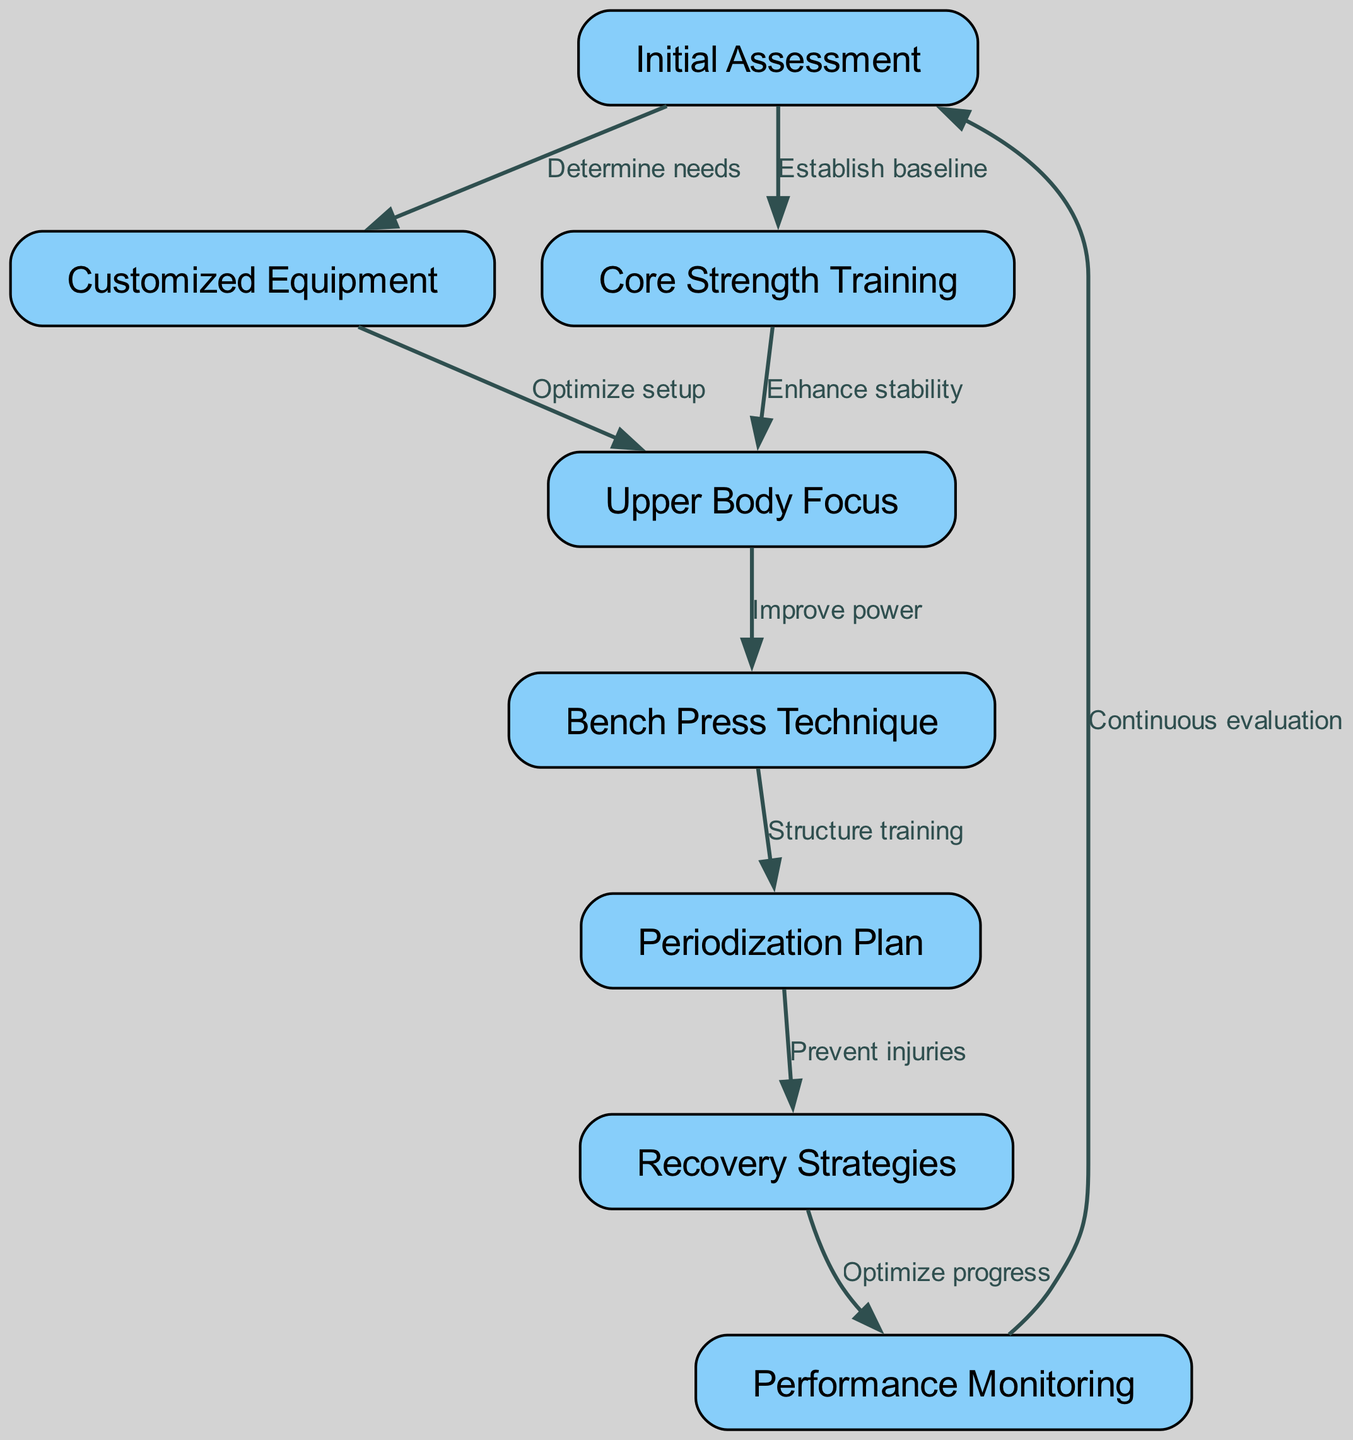What is the first step in the training program design? The first step is labeled as "Initial Assessment" in the diagram, which indicates the starting point for the entire process.
Answer: Initial Assessment How many nodes are present in the diagram? By counting the nodes listed in the data, we find that there are eight distinct nodes that represent different components of the training program design.
Answer: 8 What is the relationship between "Core Strength Training" and "Upper Body Focus"? According to the diagram, "Core Strength Training" leads to "Upper Body Focus," with the label "Enhance stability" indicating that core strength is intended to support upper body training.
Answer: Enhance stability Which node follows the "Bench Press Technique"? The node that comes after "Bench Press Technique" is "Periodization Plan," which indicates the progression into structured training following bench press skill development.
Answer: Periodization Plan What are the prevention strategies listed in the diagram? The prevention strategies indicated are conveyed in the relationship between the nodes "Periodization Plan" and "Recovery Strategies," suggesting that these strategies are implemented to prevent injuries.
Answer: Prevent injuries How does the program ensure continuous evaluation? Continuous evaluation is achieved by looping back from "Performance Monitoring" to "Initial Assessment," ensuring that the progress is consistently monitored and assessed.
Answer: Continuous evaluation What is the purpose of the "Customized Equipment" node? The setup optimized through "Customized Equipment" is determined from the "Initial Assessment," which emphasizes tailoring the equipment to meet the specific needs of the athlete.
Answer: Optimize setup Which two nodes are connected directly by the label "Improve power"? The nodes connected directly by this label are "Upper Body Focus" and "Bench Press Technique," illustrating the relationship where upper body training directly enhances bench press power.
Answer: Upper Body Focus and Bench Press Technique What is the final step in the diagram? The final step, or the output of the training program, is represented by "Performance Monitoring," which evaluates the effectiveness of the training regimen and athletic progress.
Answer: Performance Monitoring 